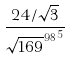Convert formula to latex. <formula><loc_0><loc_0><loc_500><loc_500>\frac { 2 4 / \sqrt { 3 } } { { \sqrt { 1 6 9 } ^ { 9 8 } } ^ { 5 } }</formula> 